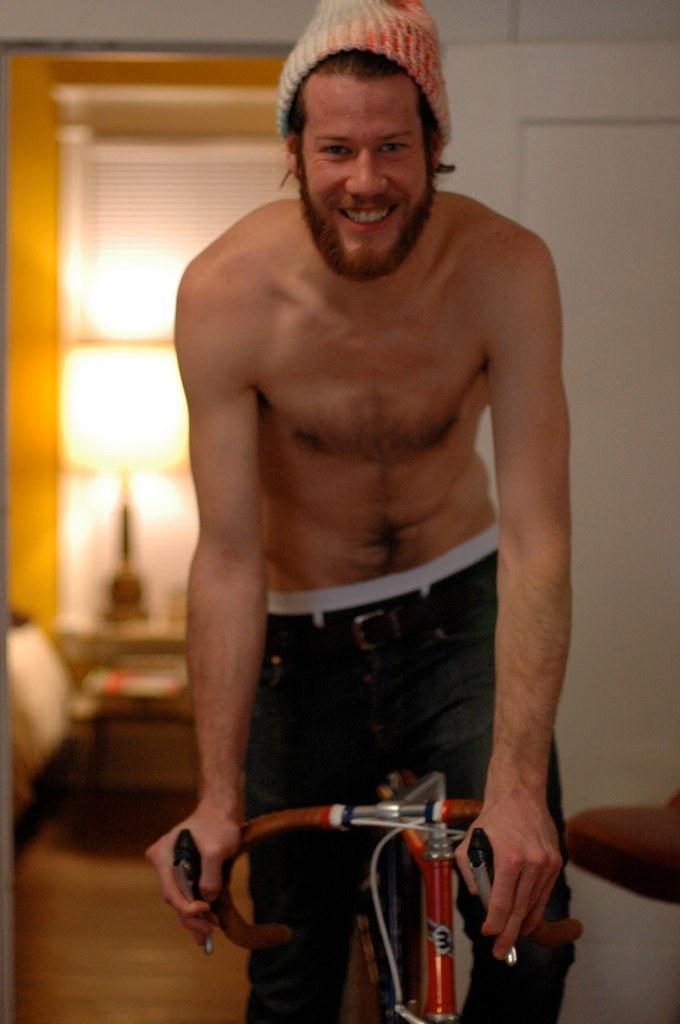In one or two sentences, can you explain what this image depicts? Here we can see a person on a bicycle , he is wearing a cap and smiling 